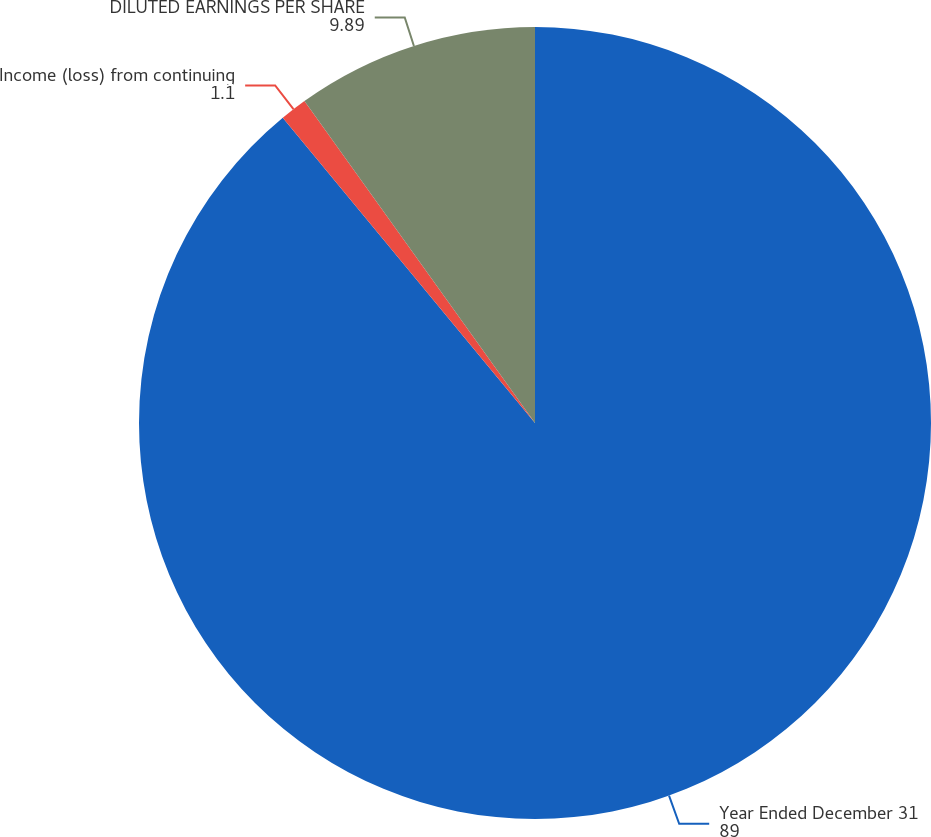<chart> <loc_0><loc_0><loc_500><loc_500><pie_chart><fcel>Year Ended December 31<fcel>Income (loss) from continuing<fcel>DILUTED EARNINGS PER SHARE<nl><fcel>89.0%<fcel>1.1%<fcel>9.89%<nl></chart> 